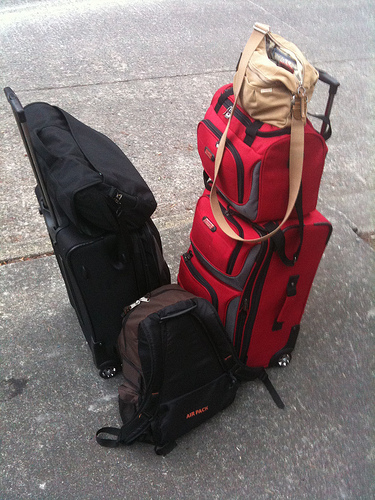Ask about the functionality and contents implied by the luggage. The luggage assortment suggests preparation for various activities; the black suitcase may contain formal attire or business materials, the red for bulkier or casual clothing, the book bag could be holding camping or hiking gear, and the purse likely stores essentials such as wallets, keys, and perhaps snacks. 